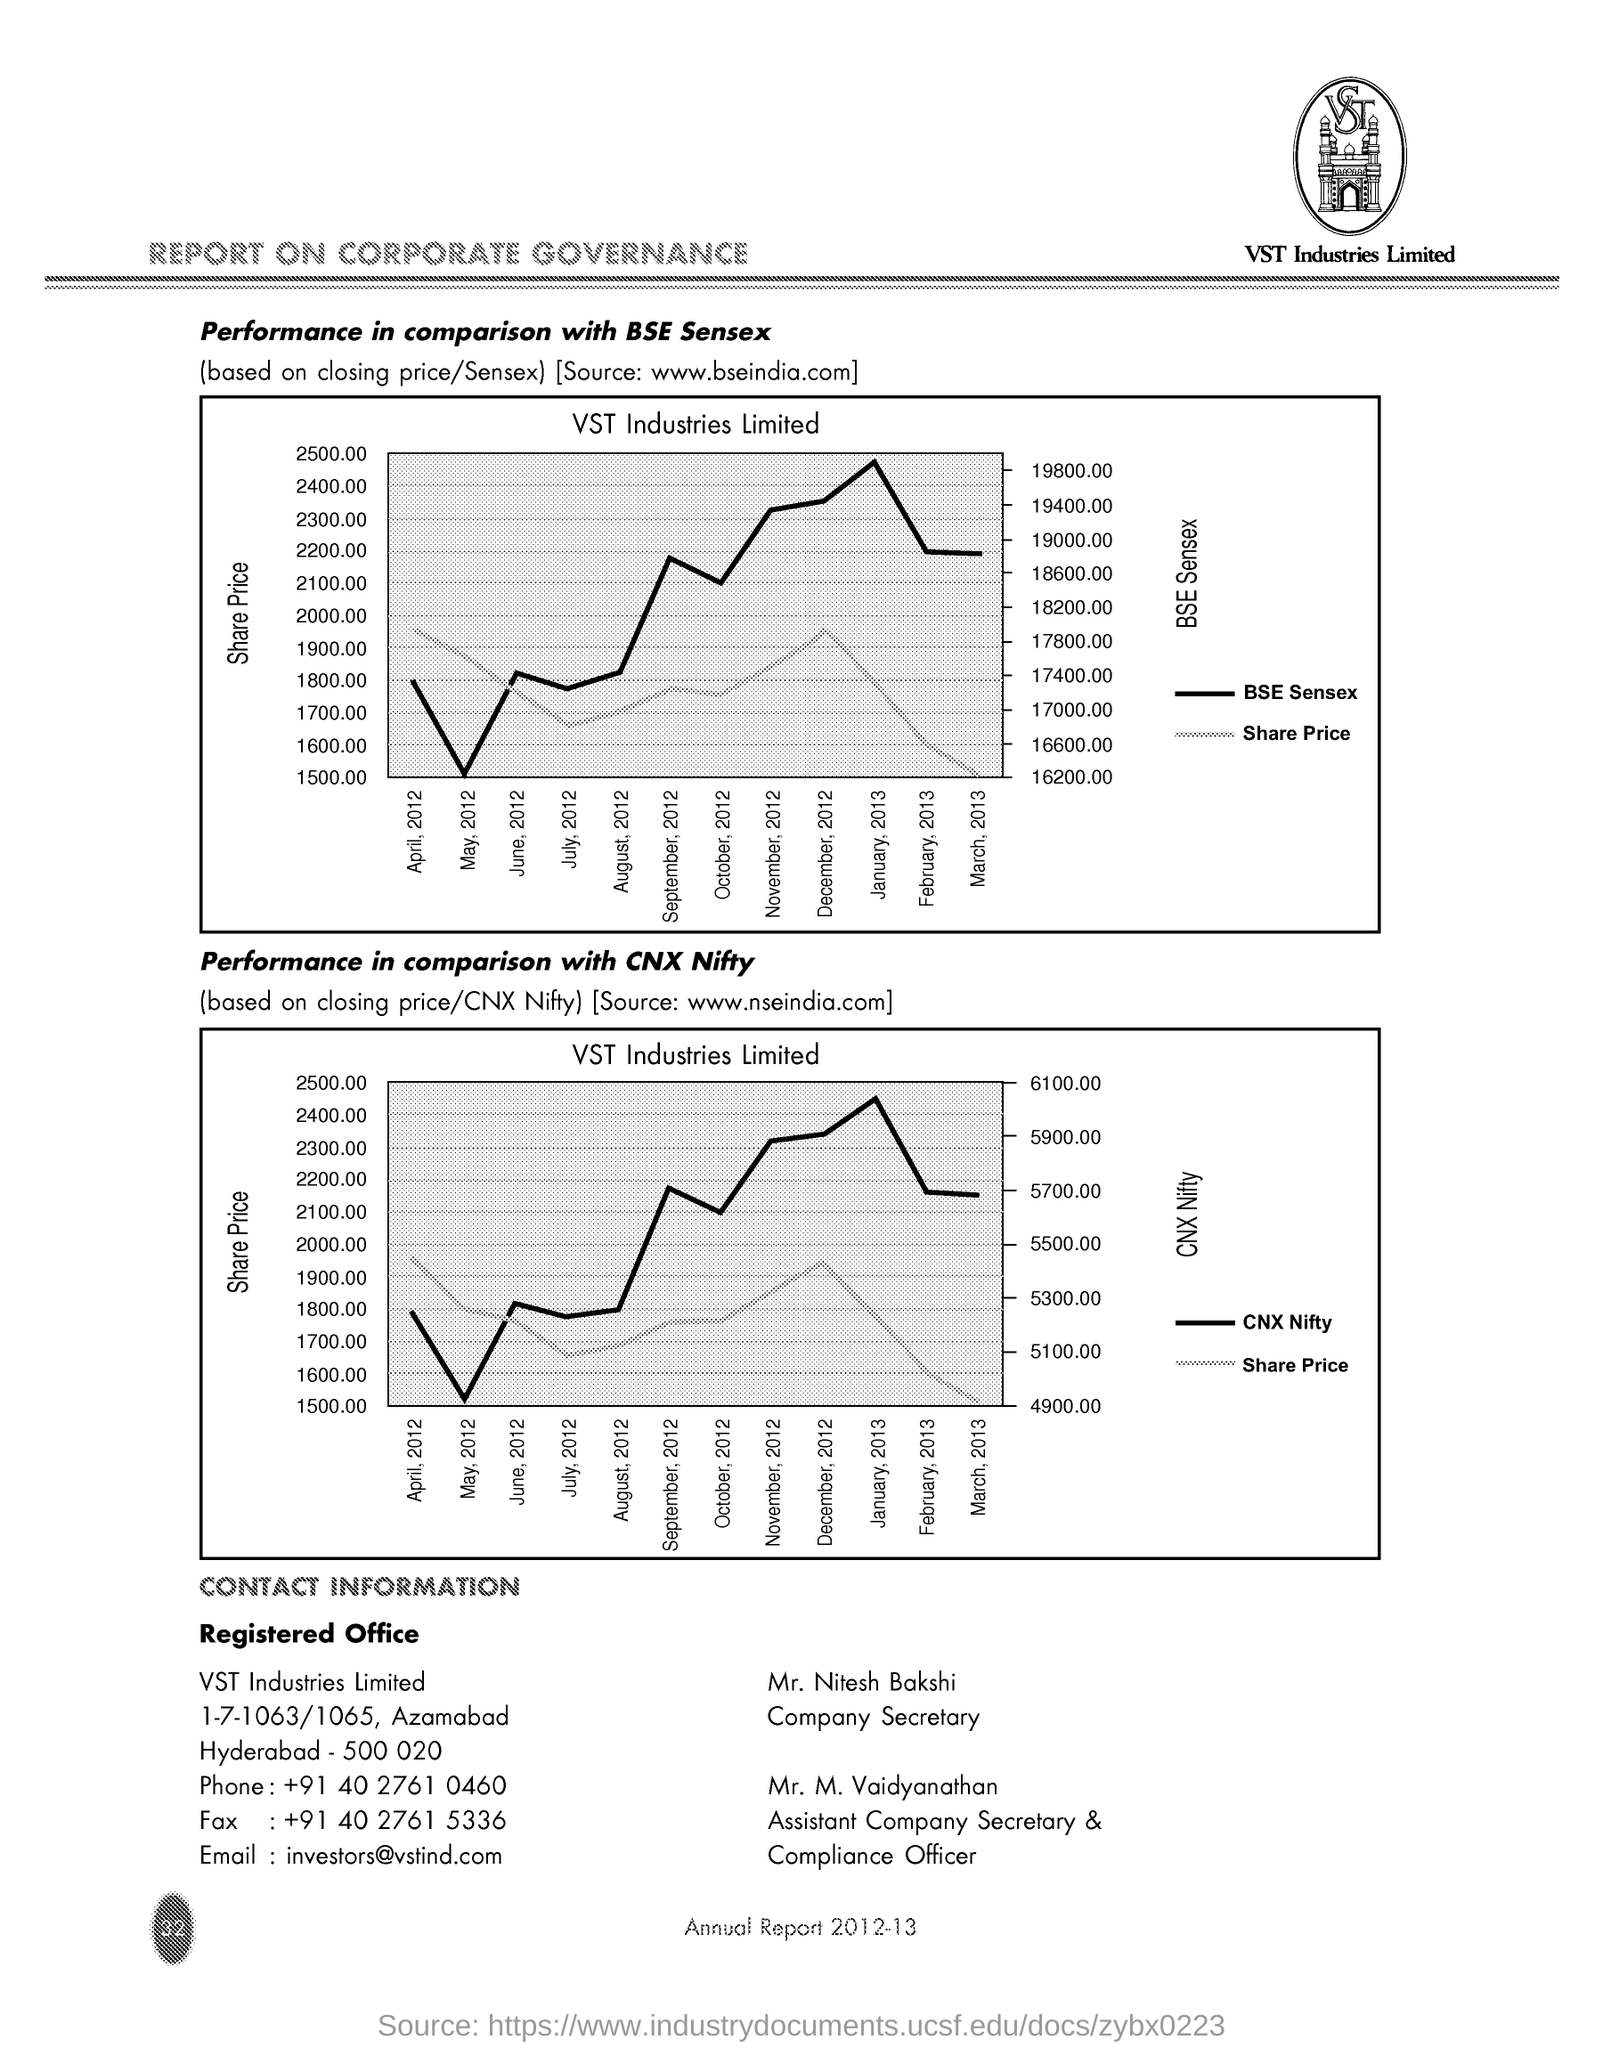Draw attention to some important aspects in this diagram. The Fax Number is +91 40 2761 5336. Mr. M. Vaidyanathan is the Assistant Company Secretary & Compliance Officer. The phone number is +91 40 2761 0460. VST Industries Limited is the industry name. The email address is "investors@vstind.com.". 